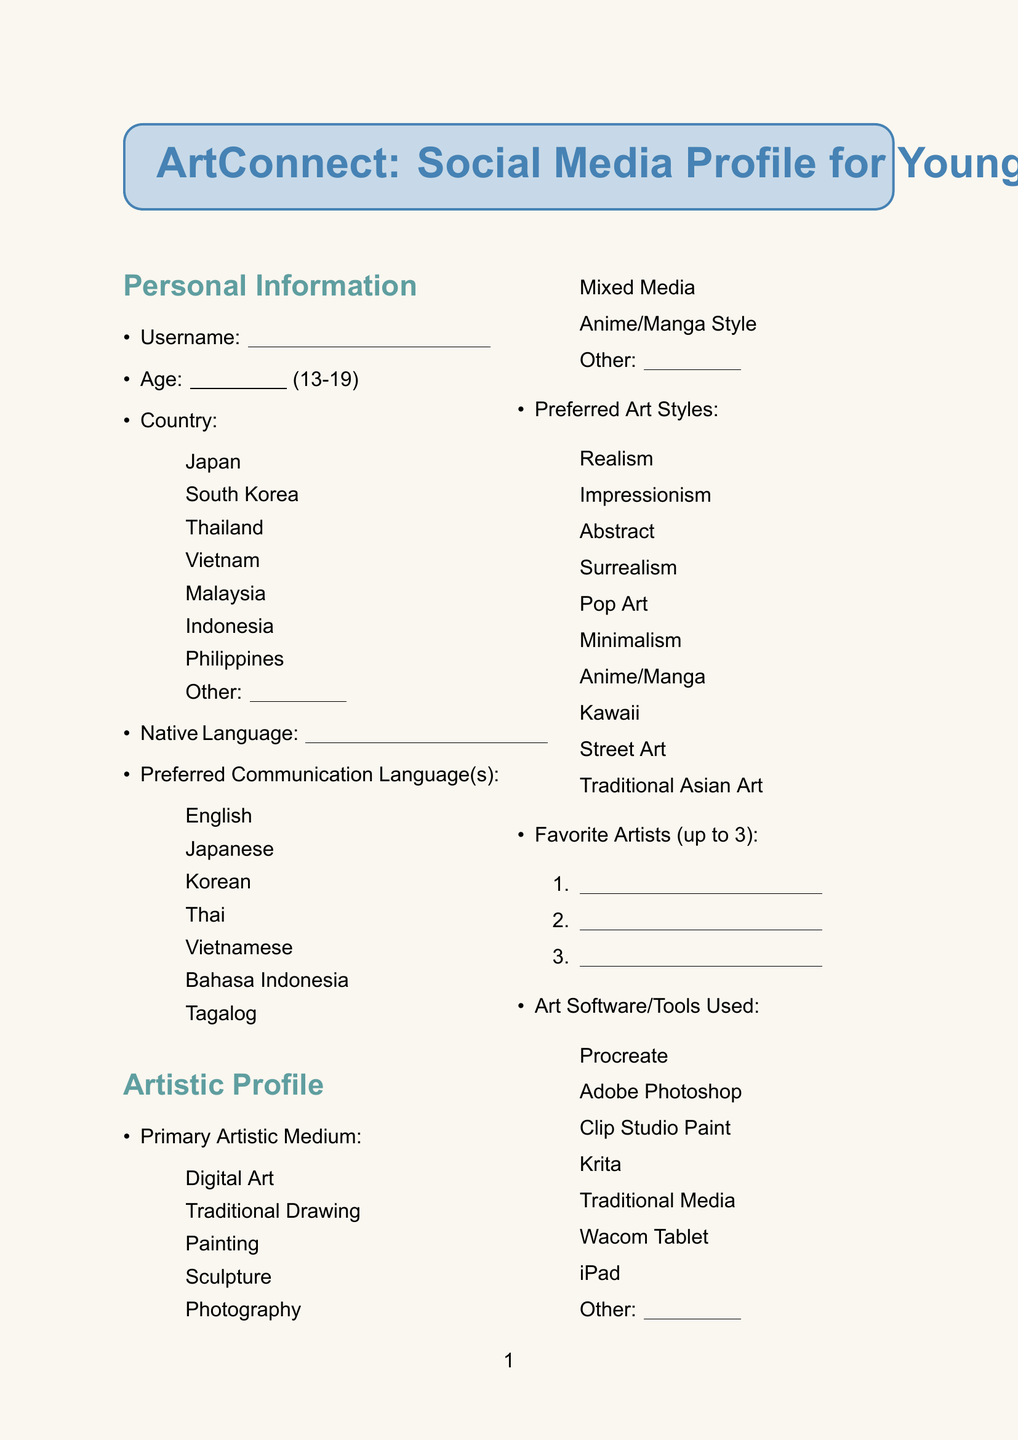What is the title of the document? The title of the document is found at the beginning, labeled clearly.
Answer: ArtConnect: Social Media Profile for Young Artists What is the minimum age allowed for profile creation? The minimum age can be found in the age field of the document.
Answer: 13 How many options are available for the primary artistic medium? The number of options can be determined by counting the listed artistic mediums.
Answer: 8 What are the options for the preferred method of interaction? The options are listed under the respective section in the document.
Answer: Comments on artwork, Direct messages, Group chats, Virtual art meetups What is the maximum character length for the bio? The maximum character length for the bio is specified in the additional information section.
Answer: 500 characters What is the checkbox option for preferred art styles? The preferred art styles are listed in a checkbox format.
Answer: Realism, Impressionism, Abstract, Surrealism, Pop Art, Minimalism, Anime/Manga, Kawaii, Street Art, Traditional Asian Art Which format is accepted for the profile picture? The accepted formats are indicated under the respective field for the profile picture.
Answer: image/jpeg, image/png, image/gif What is the slider rating scale for comfort level with sharing work? The comfort level with sharing personal work is evaluated on a slider scale.
Answer: 1 to 10 What is the purpose of the document? The purpose of the document can be inferred from the title and content structure.
Answer: To create a social media profile for young artists 